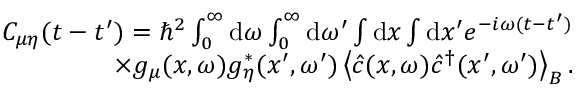<formula> <loc_0><loc_0><loc_500><loc_500>\begin{array} { r } { C _ { \mu \eta } ( t - t ^ { \prime } ) = \hbar { ^ } { 2 } \int _ { 0 } ^ { \infty } d \omega \int _ { 0 } ^ { \infty } d \omega ^ { \prime } \int d x \int d x ^ { \prime } e ^ { - i \omega ( t - t ^ { \prime } ) } } \\ { \times g _ { \mu } ( x , \omega ) g _ { \eta } ^ { * } ( x ^ { \prime } , \omega ^ { \prime } ) \left \langle \hat { c } ( x , \omega ) \hat { c } ^ { \dagger } ( x ^ { \prime } , \omega ^ { \prime } ) \right \rangle _ { B } . } \end{array}</formula> 